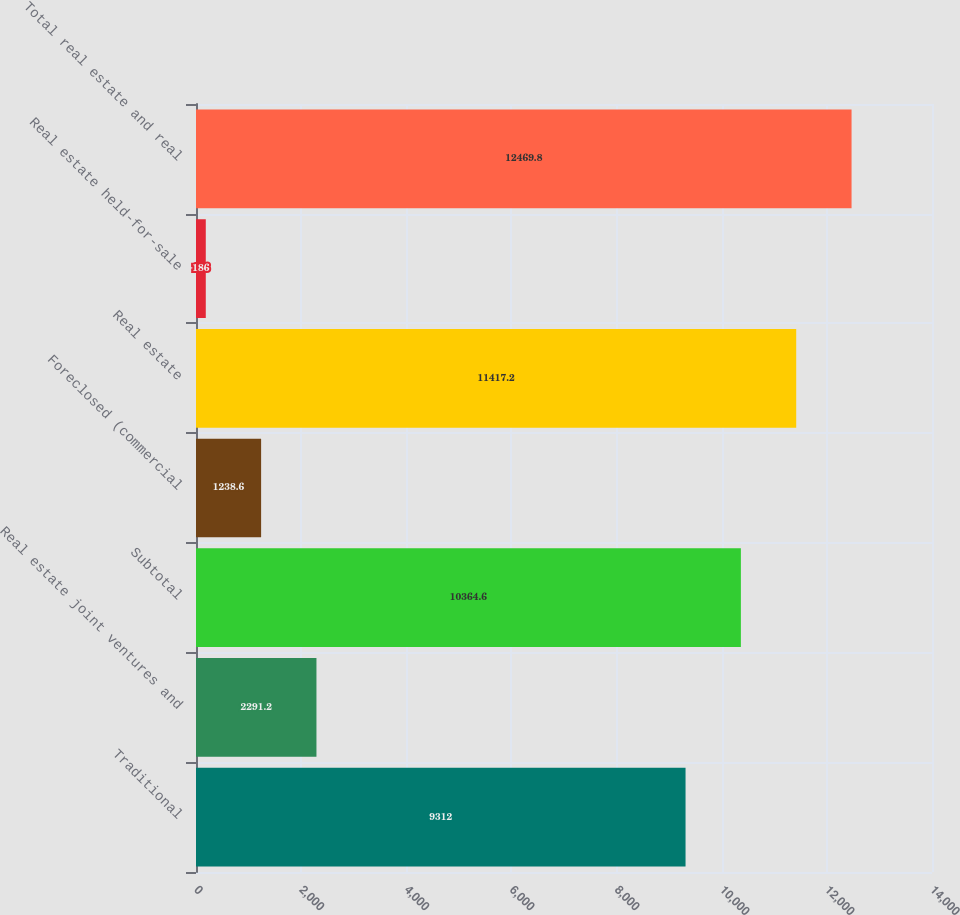Convert chart to OTSL. <chart><loc_0><loc_0><loc_500><loc_500><bar_chart><fcel>Traditional<fcel>Real estate joint ventures and<fcel>Subtotal<fcel>Foreclosed (commercial<fcel>Real estate<fcel>Real estate held-for-sale<fcel>Total real estate and real<nl><fcel>9312<fcel>2291.2<fcel>10364.6<fcel>1238.6<fcel>11417.2<fcel>186<fcel>12469.8<nl></chart> 